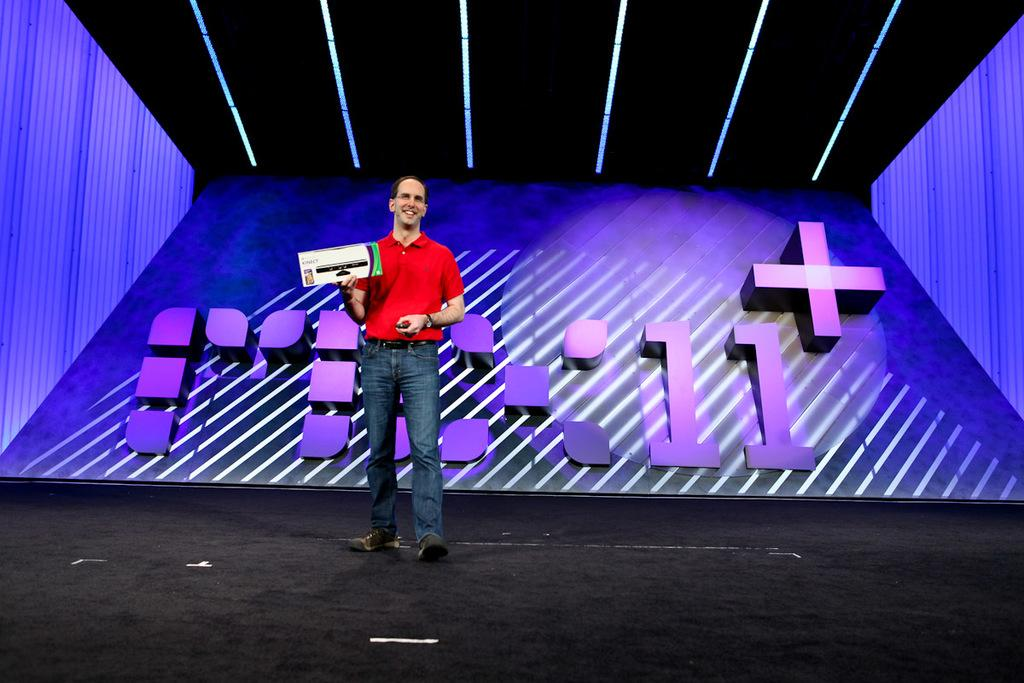What is the person in the image doing? The person is standing in the image and smiling. What is the person holding in their hand? The person is holding an object in their hand. What can be seen in the background of the image? There is a wall in the background of the image. What is written or depicted on the wall? There is text on the wall. What type of plantation can be seen in the image? There is no plantation present in the image; it features a person standing, smiling, and holding an object, with a wall and text in the background. 